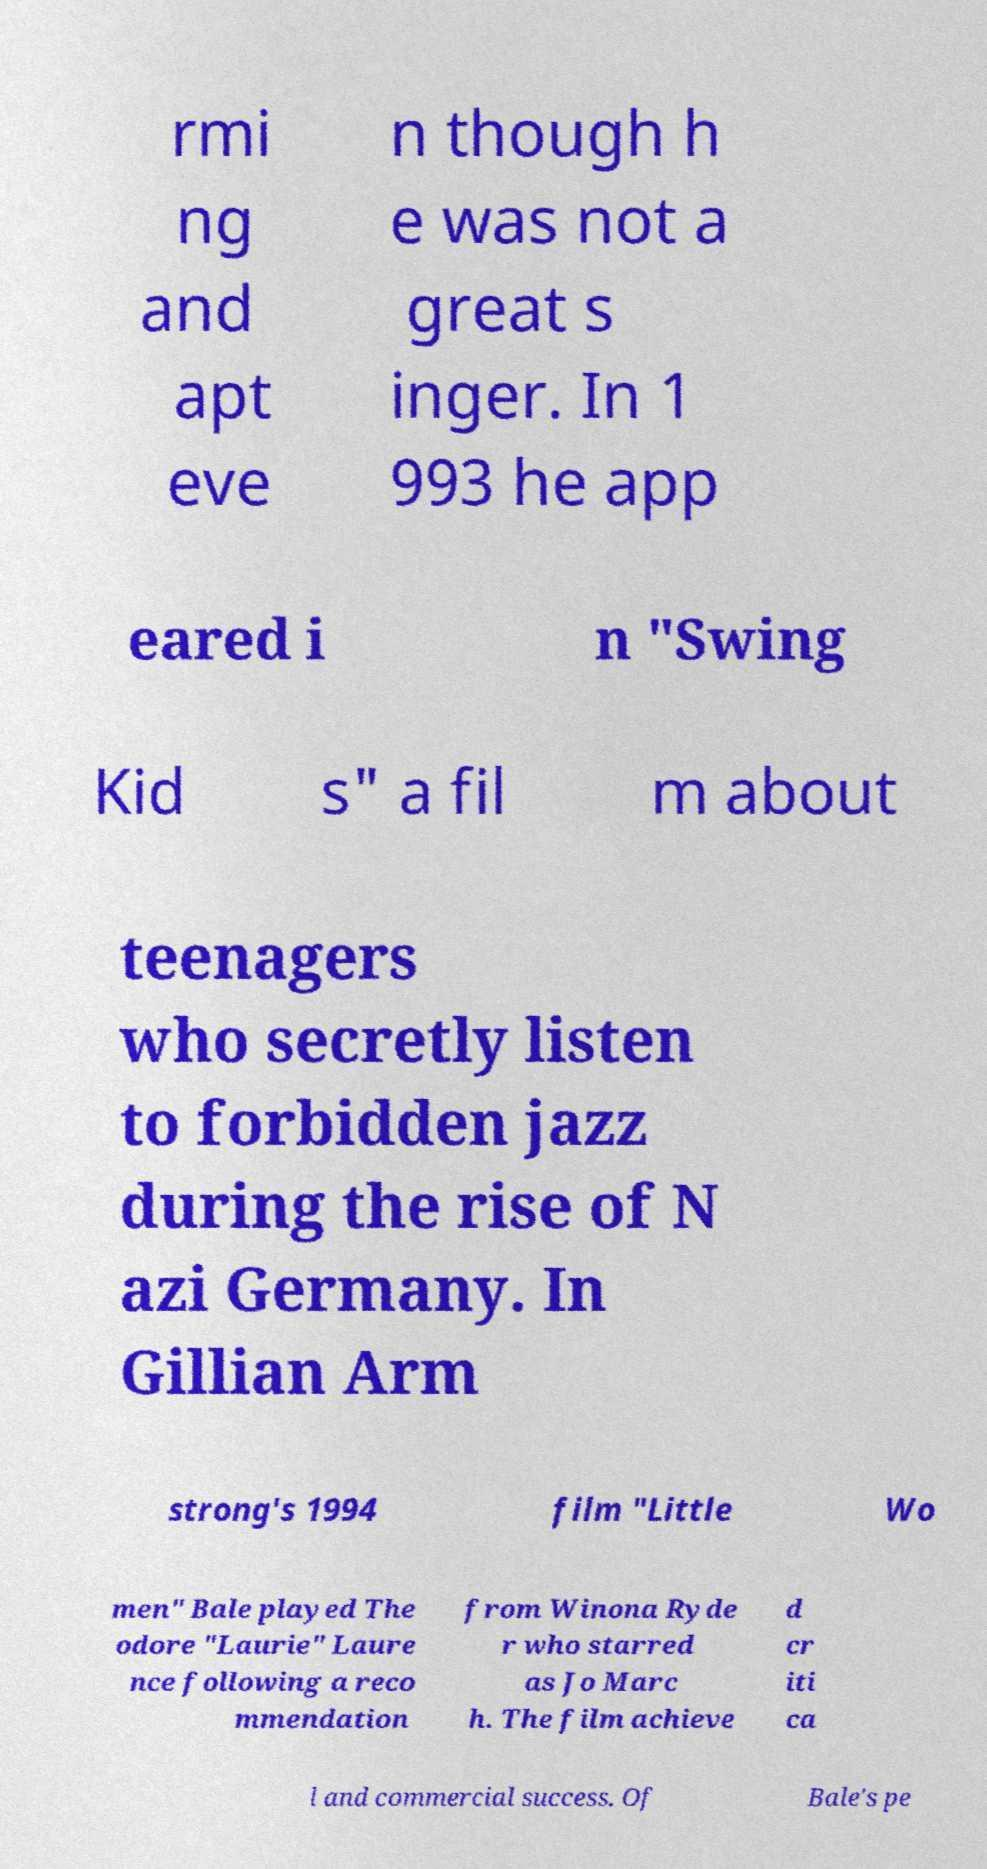What messages or text are displayed in this image? I need them in a readable, typed format. rmi ng and apt eve n though h e was not a great s inger. In 1 993 he app eared i n "Swing Kid s" a fil m about teenagers who secretly listen to forbidden jazz during the rise of N azi Germany. In Gillian Arm strong's 1994 film "Little Wo men" Bale played The odore "Laurie" Laure nce following a reco mmendation from Winona Ryde r who starred as Jo Marc h. The film achieve d cr iti ca l and commercial success. Of Bale's pe 